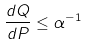<formula> <loc_0><loc_0><loc_500><loc_500>\frac { d Q } { d P } \leq \alpha ^ { - 1 }</formula> 